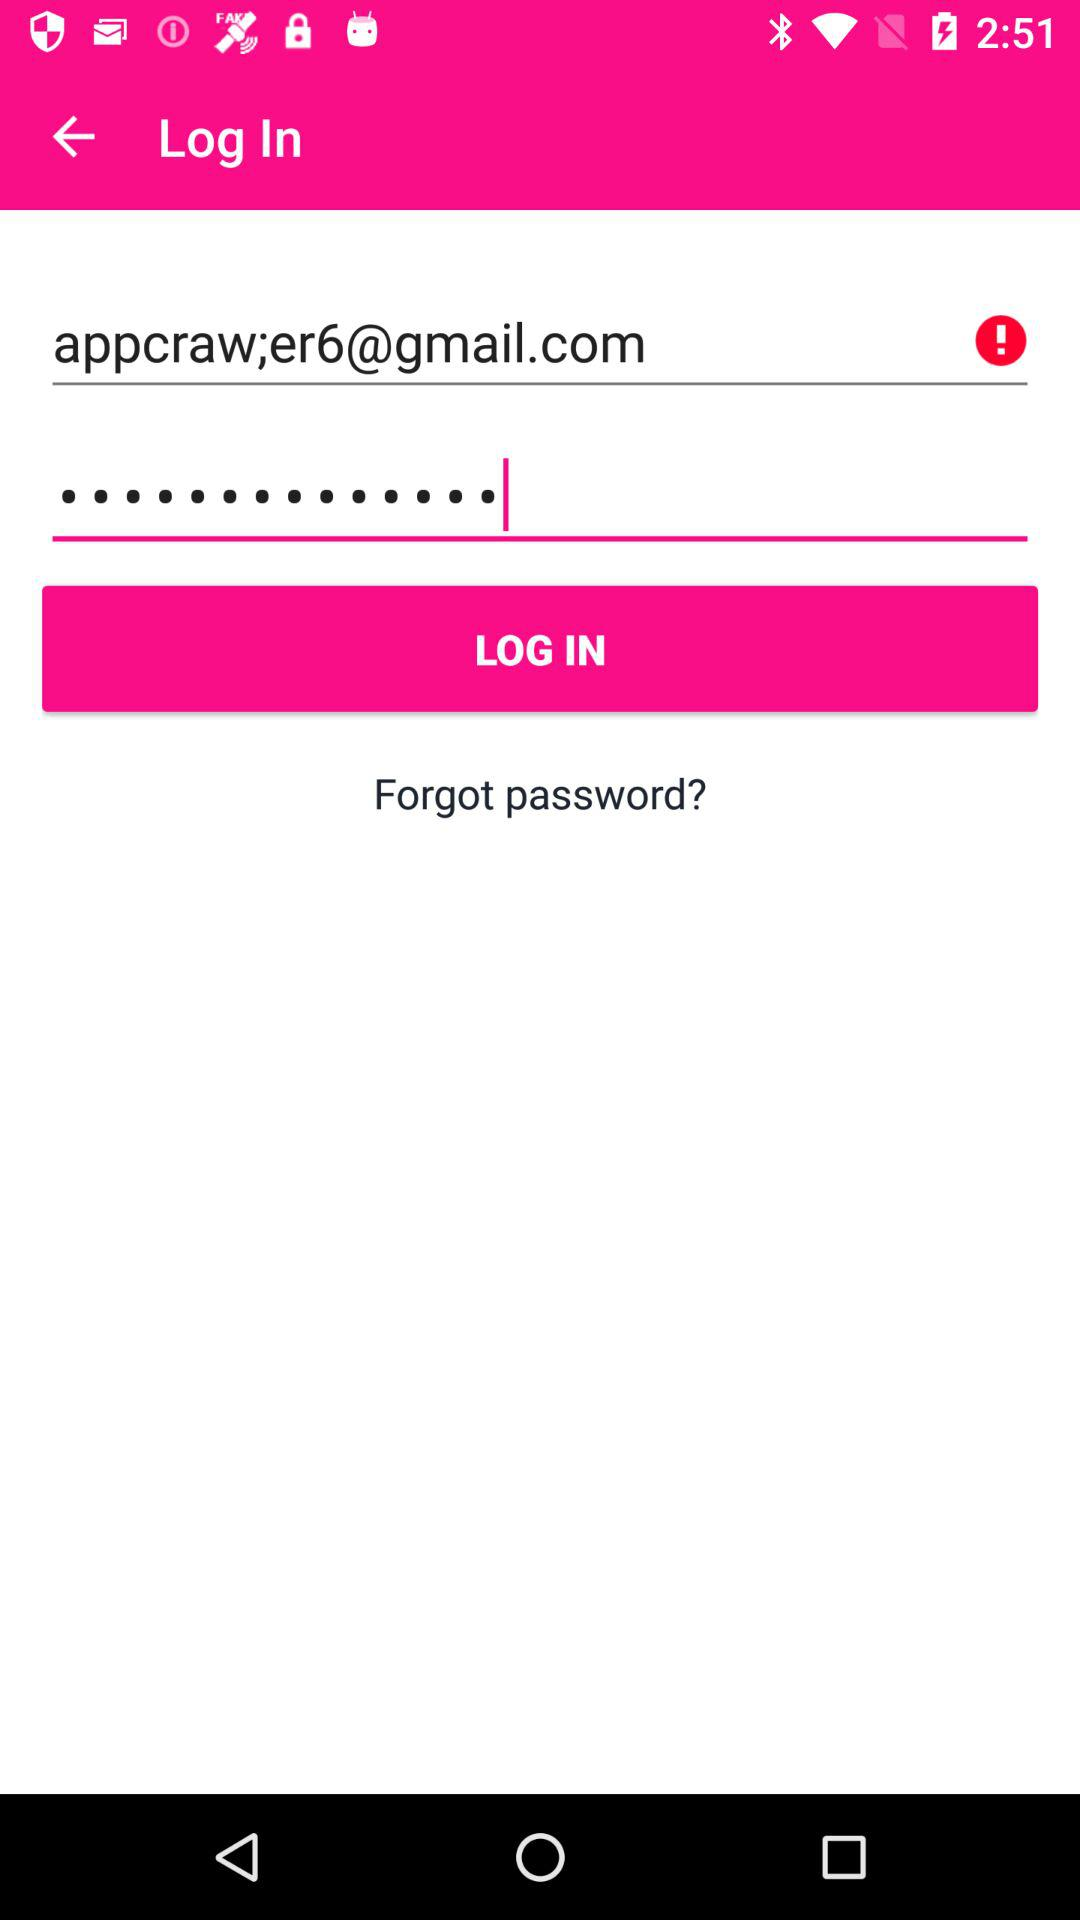What is the Gmail address? The Gmail address is appcraw;er6@gmail.com. 